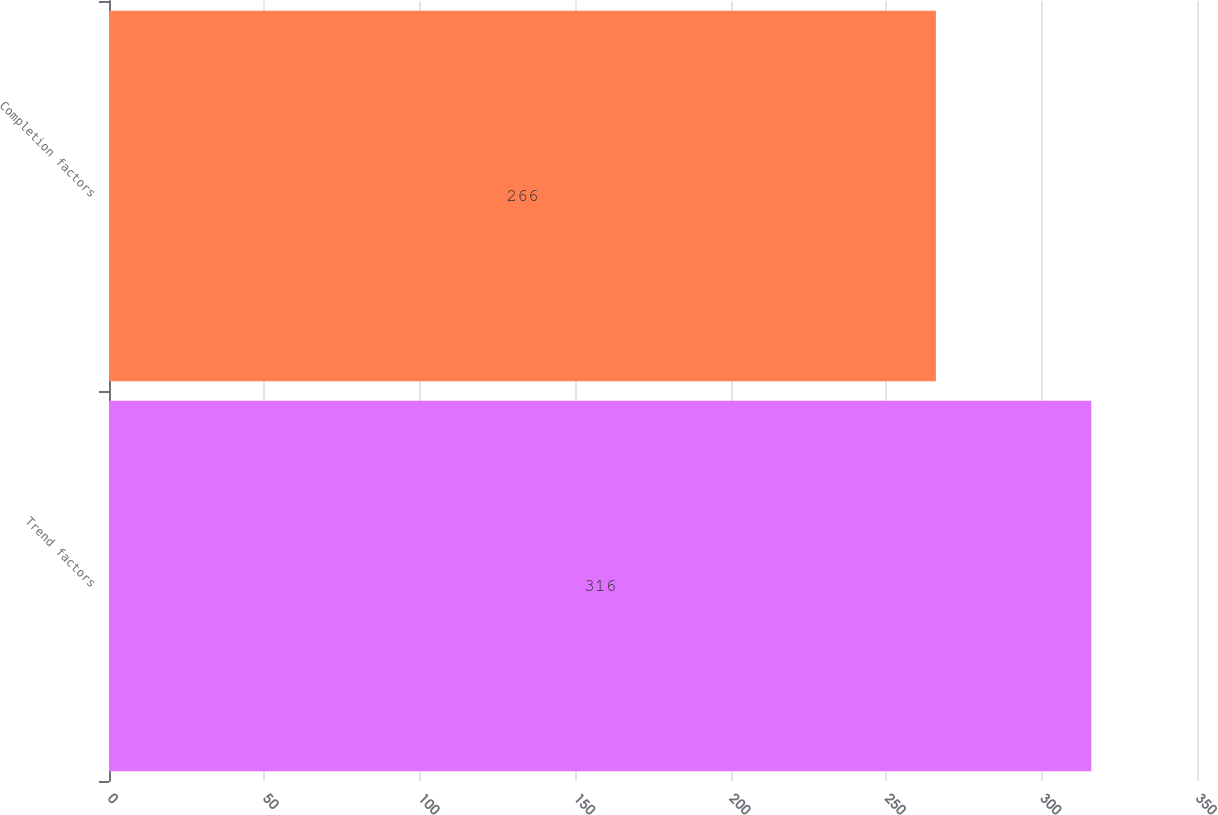Convert chart to OTSL. <chart><loc_0><loc_0><loc_500><loc_500><bar_chart><fcel>Trend factors<fcel>Completion factors<nl><fcel>316<fcel>266<nl></chart> 